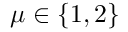<formula> <loc_0><loc_0><loc_500><loc_500>\mu \in \{ 1 , 2 \}</formula> 